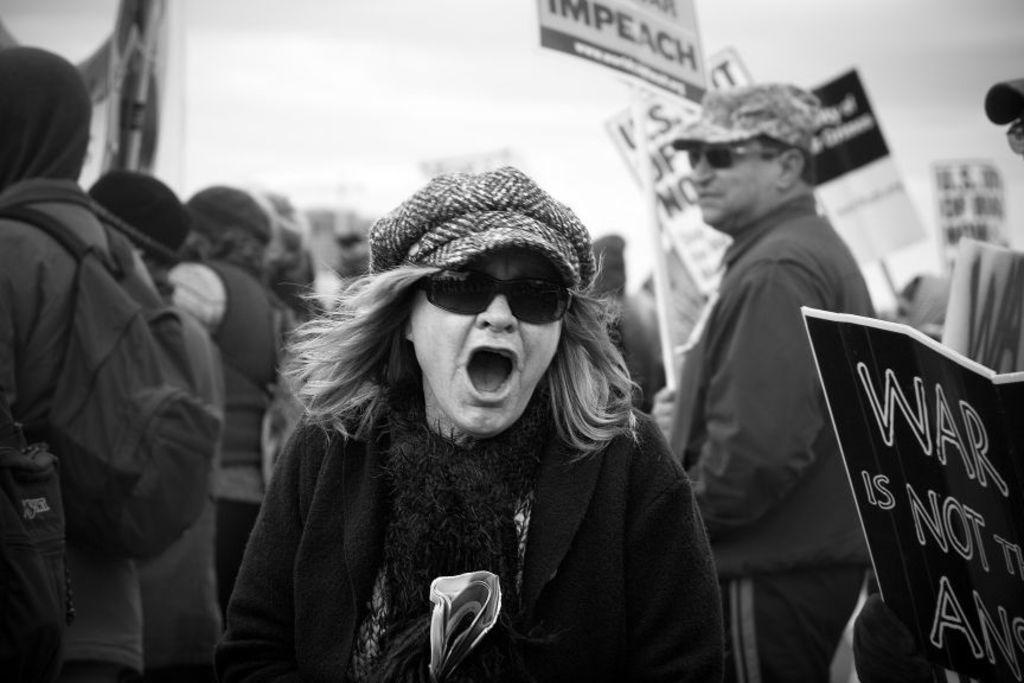What are the people in the image doing? The people in the image are standing and holding placards. What might the placards be used for? The placards might be used for expressing opinions or messages. What can be seen in the background of the image? The sky is visible in the background of the image. How many cracks can be seen on the parcel in the image? There is no parcel present in the image, so it is not possible to determine the number of cracks on it. 